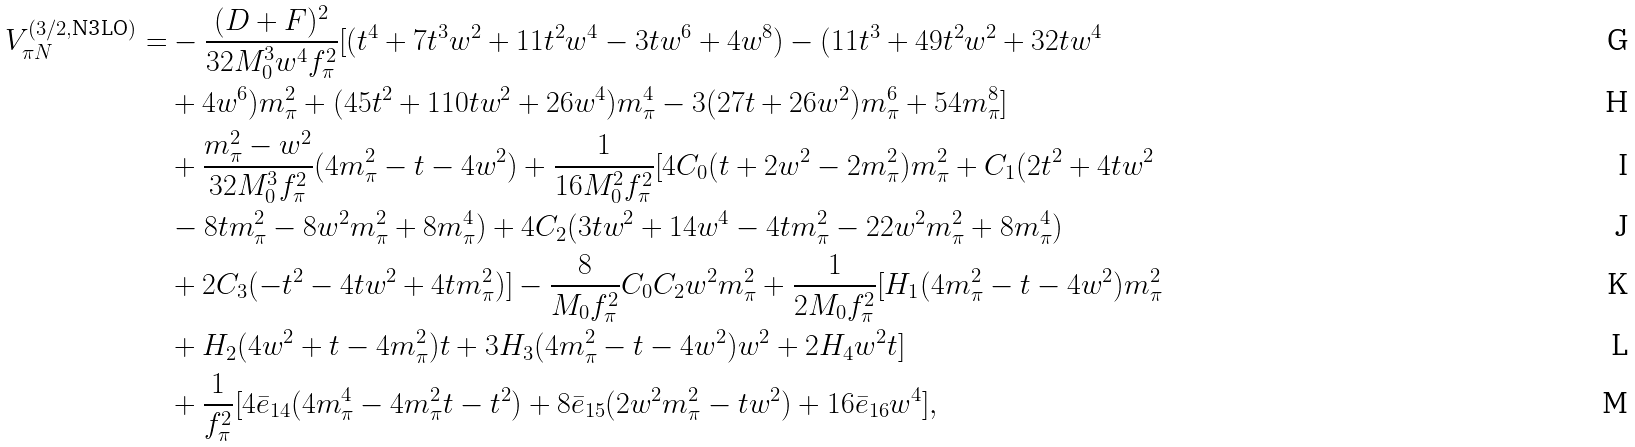<formula> <loc_0><loc_0><loc_500><loc_500>V _ { \pi N } ^ { ( 3 / 2 , \text {N3LO} ) } = & - \frac { ( D + F ) ^ { 2 } } { 3 2 M _ { 0 } ^ { 3 } w ^ { 4 } f _ { \pi } ^ { 2 } } [ ( t ^ { 4 } + 7 t ^ { 3 } w ^ { 2 } + 1 1 t ^ { 2 } w ^ { 4 } - 3 t w ^ { 6 } + 4 w ^ { 8 } ) - ( 1 1 t ^ { 3 } + 4 9 t ^ { 2 } w ^ { 2 } + 3 2 t w ^ { 4 } \\ & + 4 w ^ { 6 } ) m _ { \pi } ^ { 2 } + ( 4 5 t ^ { 2 } + 1 1 0 t w ^ { 2 } + 2 6 w ^ { 4 } ) m _ { \pi } ^ { 4 } - 3 ( 2 7 t + 2 6 w ^ { 2 } ) m _ { \pi } ^ { 6 } + 5 4 m _ { \pi } ^ { 8 } ] \\ & + \frac { m _ { \pi } ^ { 2 } - w ^ { 2 } } { 3 2 M _ { 0 } ^ { 3 } f _ { \pi } ^ { 2 } } ( 4 m _ { \pi } ^ { 2 } - t - 4 w ^ { 2 } ) + \frac { 1 } { 1 6 M _ { 0 } ^ { 2 } f _ { \pi } ^ { 2 } } [ 4 C _ { 0 } ( t + 2 w ^ { 2 } - 2 m _ { \pi } ^ { 2 } ) m _ { \pi } ^ { 2 } + C _ { 1 } ( 2 t ^ { 2 } + 4 t w ^ { 2 } \\ & - 8 t m _ { \pi } ^ { 2 } - 8 w ^ { 2 } m _ { \pi } ^ { 2 } + 8 m _ { \pi } ^ { 4 } ) + 4 C _ { 2 } ( 3 t w ^ { 2 } + 1 4 w ^ { 4 } - 4 t m _ { \pi } ^ { 2 } - 2 2 w ^ { 2 } m _ { \pi } ^ { 2 } + 8 m _ { \pi } ^ { 4 } ) \\ & + 2 C _ { 3 } ( - t ^ { 2 } - 4 t w ^ { 2 } + 4 t m _ { \pi } ^ { 2 } ) ] - \frac { 8 } { M _ { 0 } f _ { \pi } ^ { 2 } } C _ { 0 } C _ { 2 } w ^ { 2 } m _ { \pi } ^ { 2 } + \frac { 1 } { 2 M _ { 0 } f _ { \pi } ^ { 2 } } [ H _ { 1 } ( 4 m _ { \pi } ^ { 2 } - t - 4 w ^ { 2 } ) m _ { \pi } ^ { 2 } \\ & + H _ { 2 } ( 4 w ^ { 2 } + t - 4 m _ { \pi } ^ { 2 } ) t + 3 H _ { 3 } ( 4 m _ { \pi } ^ { 2 } - t - 4 w ^ { 2 } ) w ^ { 2 } + 2 H _ { 4 } w ^ { 2 } t ] \\ & + \frac { 1 } { f _ { \pi } ^ { 2 } } [ 4 \bar { e } _ { 1 4 } ( 4 m _ { \pi } ^ { 4 } - 4 m _ { \pi } ^ { 2 } t - t ^ { 2 } ) + 8 \bar { e } _ { 1 5 } ( 2 w ^ { 2 } m _ { \pi } ^ { 2 } - t w ^ { 2 } ) + 1 6 \bar { e } _ { 1 6 } w ^ { 4 } ] ,</formula> 